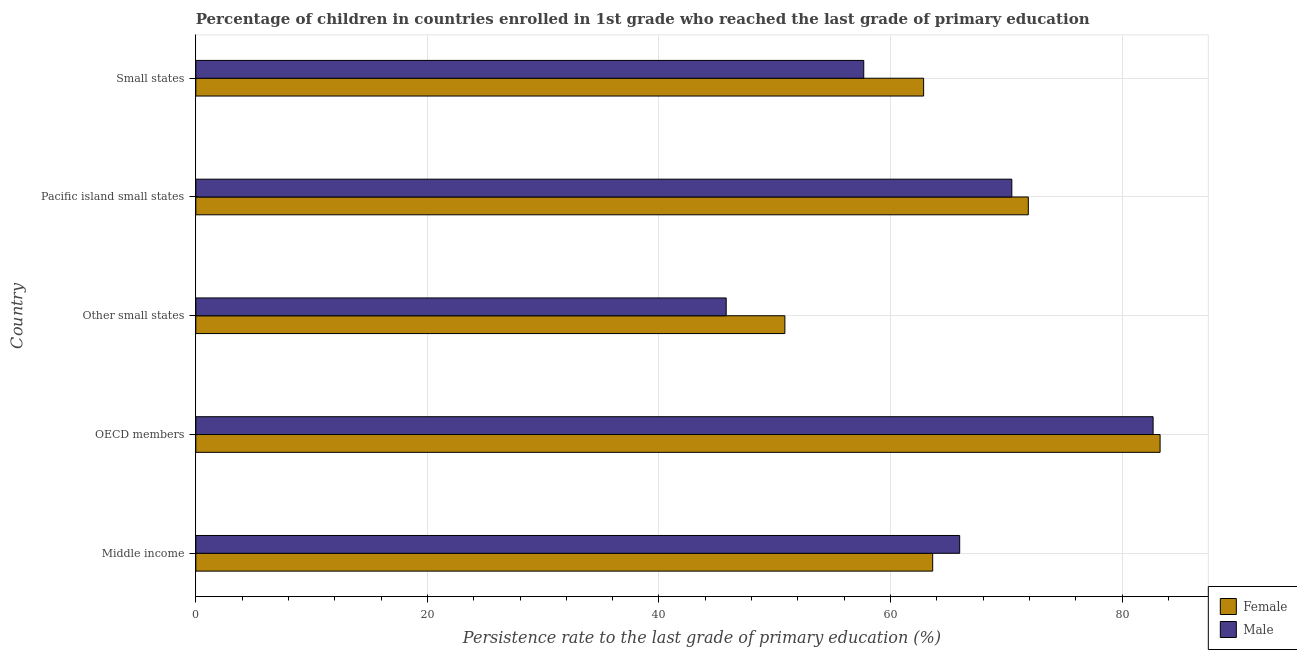How many different coloured bars are there?
Make the answer very short. 2. Are the number of bars per tick equal to the number of legend labels?
Give a very brief answer. Yes. How many bars are there on the 5th tick from the bottom?
Your response must be concise. 2. What is the label of the 5th group of bars from the top?
Provide a succinct answer. Middle income. In how many cases, is the number of bars for a given country not equal to the number of legend labels?
Offer a very short reply. 0. What is the persistence rate of male students in Middle income?
Provide a succinct answer. 65.97. Across all countries, what is the maximum persistence rate of female students?
Provide a succinct answer. 83.28. Across all countries, what is the minimum persistence rate of male students?
Ensure brevity in your answer.  45.81. In which country was the persistence rate of male students maximum?
Your answer should be very brief. OECD members. In which country was the persistence rate of male students minimum?
Offer a terse response. Other small states. What is the total persistence rate of female students in the graph?
Give a very brief answer. 332.54. What is the difference between the persistence rate of male students in Pacific island small states and that in Small states?
Offer a terse response. 12.79. What is the difference between the persistence rate of female students in Pacific island small states and the persistence rate of male students in Middle income?
Provide a short and direct response. 5.93. What is the average persistence rate of female students per country?
Offer a terse response. 66.51. What is the difference between the persistence rate of female students and persistence rate of male students in Other small states?
Offer a terse response. 5.07. What is the ratio of the persistence rate of female students in OECD members to that in Small states?
Offer a terse response. 1.32. Is the difference between the persistence rate of male students in Pacific island small states and Small states greater than the difference between the persistence rate of female students in Pacific island small states and Small states?
Make the answer very short. Yes. What is the difference between the highest and the second highest persistence rate of female students?
Offer a terse response. 11.38. What is the difference between the highest and the lowest persistence rate of male students?
Ensure brevity in your answer.  36.87. What does the 2nd bar from the top in Middle income represents?
Provide a short and direct response. Female. What does the 1st bar from the bottom in Small states represents?
Provide a short and direct response. Female. How many bars are there?
Ensure brevity in your answer.  10. What is the difference between two consecutive major ticks on the X-axis?
Your answer should be compact. 20. Where does the legend appear in the graph?
Offer a terse response. Bottom right. What is the title of the graph?
Give a very brief answer. Percentage of children in countries enrolled in 1st grade who reached the last grade of primary education. What is the label or title of the X-axis?
Provide a succinct answer. Persistence rate to the last grade of primary education (%). What is the label or title of the Y-axis?
Ensure brevity in your answer.  Country. What is the Persistence rate to the last grade of primary education (%) of Female in Middle income?
Your answer should be compact. 63.64. What is the Persistence rate to the last grade of primary education (%) in Male in Middle income?
Keep it short and to the point. 65.97. What is the Persistence rate to the last grade of primary education (%) in Female in OECD members?
Ensure brevity in your answer.  83.28. What is the Persistence rate to the last grade of primary education (%) in Male in OECD members?
Ensure brevity in your answer.  82.67. What is the Persistence rate to the last grade of primary education (%) in Female in Other small states?
Keep it short and to the point. 50.87. What is the Persistence rate to the last grade of primary education (%) in Male in Other small states?
Offer a very short reply. 45.81. What is the Persistence rate to the last grade of primary education (%) in Female in Pacific island small states?
Keep it short and to the point. 71.9. What is the Persistence rate to the last grade of primary education (%) in Male in Pacific island small states?
Your response must be concise. 70.47. What is the Persistence rate to the last grade of primary education (%) in Female in Small states?
Make the answer very short. 62.85. What is the Persistence rate to the last grade of primary education (%) in Male in Small states?
Give a very brief answer. 57.68. Across all countries, what is the maximum Persistence rate to the last grade of primary education (%) in Female?
Provide a succinct answer. 83.28. Across all countries, what is the maximum Persistence rate to the last grade of primary education (%) in Male?
Offer a very short reply. 82.67. Across all countries, what is the minimum Persistence rate to the last grade of primary education (%) of Female?
Your response must be concise. 50.87. Across all countries, what is the minimum Persistence rate to the last grade of primary education (%) in Male?
Give a very brief answer. 45.81. What is the total Persistence rate to the last grade of primary education (%) in Female in the graph?
Ensure brevity in your answer.  332.54. What is the total Persistence rate to the last grade of primary education (%) in Male in the graph?
Your response must be concise. 322.6. What is the difference between the Persistence rate to the last grade of primary education (%) in Female in Middle income and that in OECD members?
Make the answer very short. -19.64. What is the difference between the Persistence rate to the last grade of primary education (%) in Male in Middle income and that in OECD members?
Your response must be concise. -16.7. What is the difference between the Persistence rate to the last grade of primary education (%) in Female in Middle income and that in Other small states?
Offer a very short reply. 12.77. What is the difference between the Persistence rate to the last grade of primary education (%) of Male in Middle income and that in Other small states?
Offer a terse response. 20.16. What is the difference between the Persistence rate to the last grade of primary education (%) of Female in Middle income and that in Pacific island small states?
Give a very brief answer. -8.26. What is the difference between the Persistence rate to the last grade of primary education (%) in Male in Middle income and that in Pacific island small states?
Offer a very short reply. -4.5. What is the difference between the Persistence rate to the last grade of primary education (%) in Female in Middle income and that in Small states?
Provide a succinct answer. 0.78. What is the difference between the Persistence rate to the last grade of primary education (%) of Male in Middle income and that in Small states?
Your answer should be compact. 8.29. What is the difference between the Persistence rate to the last grade of primary education (%) in Female in OECD members and that in Other small states?
Keep it short and to the point. 32.41. What is the difference between the Persistence rate to the last grade of primary education (%) of Male in OECD members and that in Other small states?
Ensure brevity in your answer.  36.87. What is the difference between the Persistence rate to the last grade of primary education (%) of Female in OECD members and that in Pacific island small states?
Your answer should be very brief. 11.38. What is the difference between the Persistence rate to the last grade of primary education (%) in Male in OECD members and that in Pacific island small states?
Your response must be concise. 12.2. What is the difference between the Persistence rate to the last grade of primary education (%) in Female in OECD members and that in Small states?
Your response must be concise. 20.42. What is the difference between the Persistence rate to the last grade of primary education (%) of Male in OECD members and that in Small states?
Provide a succinct answer. 24.99. What is the difference between the Persistence rate to the last grade of primary education (%) in Female in Other small states and that in Pacific island small states?
Your response must be concise. -21.02. What is the difference between the Persistence rate to the last grade of primary education (%) in Male in Other small states and that in Pacific island small states?
Provide a succinct answer. -24.67. What is the difference between the Persistence rate to the last grade of primary education (%) of Female in Other small states and that in Small states?
Provide a short and direct response. -11.98. What is the difference between the Persistence rate to the last grade of primary education (%) of Male in Other small states and that in Small states?
Provide a short and direct response. -11.88. What is the difference between the Persistence rate to the last grade of primary education (%) in Female in Pacific island small states and that in Small states?
Your response must be concise. 9.04. What is the difference between the Persistence rate to the last grade of primary education (%) in Male in Pacific island small states and that in Small states?
Offer a terse response. 12.79. What is the difference between the Persistence rate to the last grade of primary education (%) of Female in Middle income and the Persistence rate to the last grade of primary education (%) of Male in OECD members?
Your answer should be compact. -19.04. What is the difference between the Persistence rate to the last grade of primary education (%) in Female in Middle income and the Persistence rate to the last grade of primary education (%) in Male in Other small states?
Your response must be concise. 17.83. What is the difference between the Persistence rate to the last grade of primary education (%) in Female in Middle income and the Persistence rate to the last grade of primary education (%) in Male in Pacific island small states?
Offer a very short reply. -6.84. What is the difference between the Persistence rate to the last grade of primary education (%) in Female in Middle income and the Persistence rate to the last grade of primary education (%) in Male in Small states?
Ensure brevity in your answer.  5.95. What is the difference between the Persistence rate to the last grade of primary education (%) of Female in OECD members and the Persistence rate to the last grade of primary education (%) of Male in Other small states?
Provide a succinct answer. 37.47. What is the difference between the Persistence rate to the last grade of primary education (%) of Female in OECD members and the Persistence rate to the last grade of primary education (%) of Male in Pacific island small states?
Make the answer very short. 12.8. What is the difference between the Persistence rate to the last grade of primary education (%) in Female in OECD members and the Persistence rate to the last grade of primary education (%) in Male in Small states?
Offer a terse response. 25.59. What is the difference between the Persistence rate to the last grade of primary education (%) of Female in Other small states and the Persistence rate to the last grade of primary education (%) of Male in Pacific island small states?
Provide a succinct answer. -19.6. What is the difference between the Persistence rate to the last grade of primary education (%) of Female in Other small states and the Persistence rate to the last grade of primary education (%) of Male in Small states?
Your answer should be very brief. -6.81. What is the difference between the Persistence rate to the last grade of primary education (%) in Female in Pacific island small states and the Persistence rate to the last grade of primary education (%) in Male in Small states?
Keep it short and to the point. 14.21. What is the average Persistence rate to the last grade of primary education (%) in Female per country?
Your answer should be very brief. 66.51. What is the average Persistence rate to the last grade of primary education (%) in Male per country?
Provide a short and direct response. 64.52. What is the difference between the Persistence rate to the last grade of primary education (%) in Female and Persistence rate to the last grade of primary education (%) in Male in Middle income?
Make the answer very short. -2.33. What is the difference between the Persistence rate to the last grade of primary education (%) in Female and Persistence rate to the last grade of primary education (%) in Male in OECD members?
Keep it short and to the point. 0.6. What is the difference between the Persistence rate to the last grade of primary education (%) in Female and Persistence rate to the last grade of primary education (%) in Male in Other small states?
Your answer should be compact. 5.07. What is the difference between the Persistence rate to the last grade of primary education (%) in Female and Persistence rate to the last grade of primary education (%) in Male in Pacific island small states?
Keep it short and to the point. 1.42. What is the difference between the Persistence rate to the last grade of primary education (%) in Female and Persistence rate to the last grade of primary education (%) in Male in Small states?
Keep it short and to the point. 5.17. What is the ratio of the Persistence rate to the last grade of primary education (%) of Female in Middle income to that in OECD members?
Make the answer very short. 0.76. What is the ratio of the Persistence rate to the last grade of primary education (%) in Male in Middle income to that in OECD members?
Keep it short and to the point. 0.8. What is the ratio of the Persistence rate to the last grade of primary education (%) of Female in Middle income to that in Other small states?
Give a very brief answer. 1.25. What is the ratio of the Persistence rate to the last grade of primary education (%) in Male in Middle income to that in Other small states?
Keep it short and to the point. 1.44. What is the ratio of the Persistence rate to the last grade of primary education (%) of Female in Middle income to that in Pacific island small states?
Provide a short and direct response. 0.89. What is the ratio of the Persistence rate to the last grade of primary education (%) in Male in Middle income to that in Pacific island small states?
Give a very brief answer. 0.94. What is the ratio of the Persistence rate to the last grade of primary education (%) of Female in Middle income to that in Small states?
Offer a terse response. 1.01. What is the ratio of the Persistence rate to the last grade of primary education (%) in Male in Middle income to that in Small states?
Your answer should be compact. 1.14. What is the ratio of the Persistence rate to the last grade of primary education (%) of Female in OECD members to that in Other small states?
Offer a terse response. 1.64. What is the ratio of the Persistence rate to the last grade of primary education (%) of Male in OECD members to that in Other small states?
Give a very brief answer. 1.8. What is the ratio of the Persistence rate to the last grade of primary education (%) of Female in OECD members to that in Pacific island small states?
Provide a short and direct response. 1.16. What is the ratio of the Persistence rate to the last grade of primary education (%) in Male in OECD members to that in Pacific island small states?
Give a very brief answer. 1.17. What is the ratio of the Persistence rate to the last grade of primary education (%) of Female in OECD members to that in Small states?
Provide a short and direct response. 1.32. What is the ratio of the Persistence rate to the last grade of primary education (%) of Male in OECD members to that in Small states?
Your response must be concise. 1.43. What is the ratio of the Persistence rate to the last grade of primary education (%) in Female in Other small states to that in Pacific island small states?
Your answer should be compact. 0.71. What is the ratio of the Persistence rate to the last grade of primary education (%) in Male in Other small states to that in Pacific island small states?
Keep it short and to the point. 0.65. What is the ratio of the Persistence rate to the last grade of primary education (%) in Female in Other small states to that in Small states?
Provide a succinct answer. 0.81. What is the ratio of the Persistence rate to the last grade of primary education (%) of Male in Other small states to that in Small states?
Offer a very short reply. 0.79. What is the ratio of the Persistence rate to the last grade of primary education (%) in Female in Pacific island small states to that in Small states?
Give a very brief answer. 1.14. What is the ratio of the Persistence rate to the last grade of primary education (%) of Male in Pacific island small states to that in Small states?
Keep it short and to the point. 1.22. What is the difference between the highest and the second highest Persistence rate to the last grade of primary education (%) in Female?
Your response must be concise. 11.38. What is the difference between the highest and the second highest Persistence rate to the last grade of primary education (%) in Male?
Your answer should be very brief. 12.2. What is the difference between the highest and the lowest Persistence rate to the last grade of primary education (%) of Female?
Your response must be concise. 32.41. What is the difference between the highest and the lowest Persistence rate to the last grade of primary education (%) in Male?
Provide a short and direct response. 36.87. 